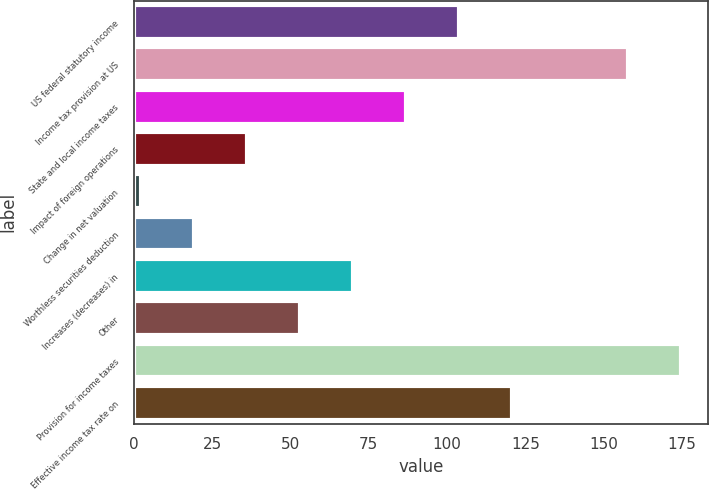<chart> <loc_0><loc_0><loc_500><loc_500><bar_chart><fcel>US federal statutory income<fcel>Income tax provision at US<fcel>State and local income taxes<fcel>Impact of foreign operations<fcel>Change in net valuation<fcel>Worthless securities deduction<fcel>Increases (decreases) in<fcel>Other<fcel>Provision for income taxes<fcel>Effective income tax rate on<nl><fcel>103.74<fcel>157.7<fcel>86.85<fcel>36.18<fcel>2.4<fcel>19.29<fcel>69.96<fcel>53.07<fcel>174.59<fcel>120.63<nl></chart> 